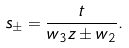Convert formula to latex. <formula><loc_0><loc_0><loc_500><loc_500>s _ { \pm } = \frac { t } { w _ { 3 } z \pm w _ { 2 } } .</formula> 